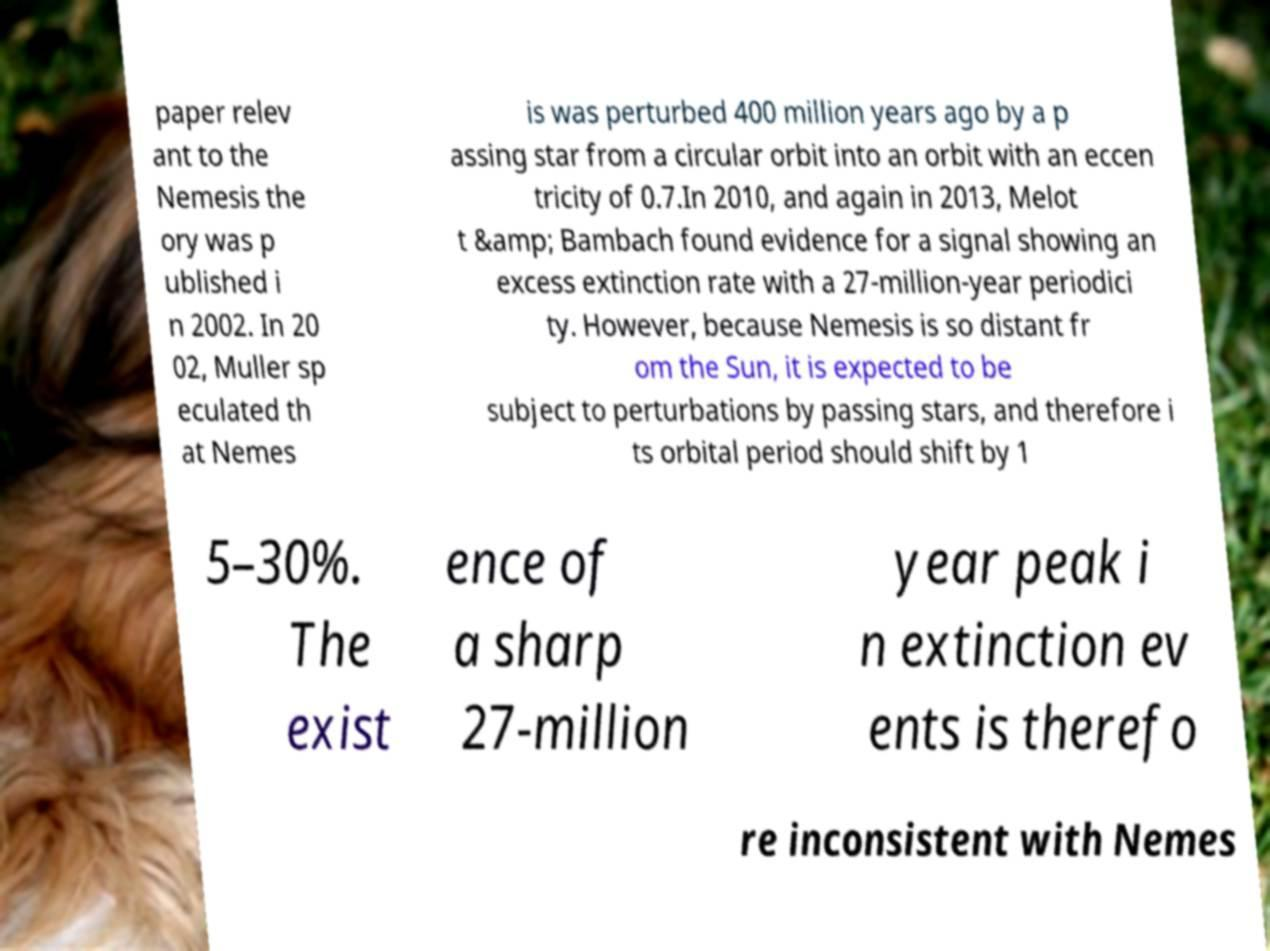Can you accurately transcribe the text from the provided image for me? paper relev ant to the Nemesis the ory was p ublished i n 2002. In 20 02, Muller sp eculated th at Nemes is was perturbed 400 million years ago by a p assing star from a circular orbit into an orbit with an eccen tricity of 0.7.In 2010, and again in 2013, Melot t &amp; Bambach found evidence for a signal showing an excess extinction rate with a 27-million-year periodici ty. However, because Nemesis is so distant fr om the Sun, it is expected to be subject to perturbations by passing stars, and therefore i ts orbital period should shift by 1 5–30%. The exist ence of a sharp 27-million year peak i n extinction ev ents is therefo re inconsistent with Nemes 